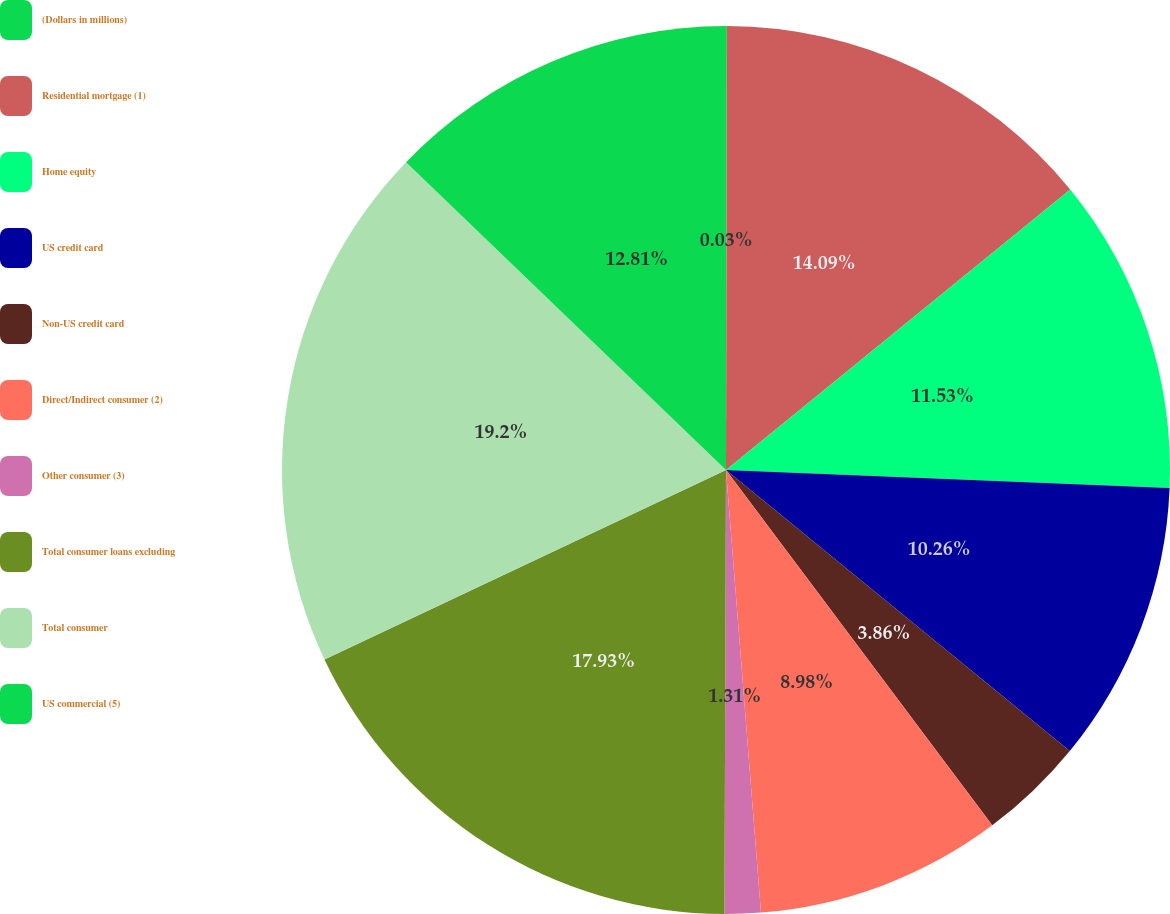Convert chart to OTSL. <chart><loc_0><loc_0><loc_500><loc_500><pie_chart><fcel>(Dollars in millions)<fcel>Residential mortgage (1)<fcel>Home equity<fcel>US credit card<fcel>Non-US credit card<fcel>Direct/Indirect consumer (2)<fcel>Other consumer (3)<fcel>Total consumer loans excluding<fcel>Total consumer<fcel>US commercial (5)<nl><fcel>0.03%<fcel>14.09%<fcel>11.53%<fcel>10.26%<fcel>3.86%<fcel>8.98%<fcel>1.31%<fcel>17.93%<fcel>19.21%<fcel>12.81%<nl></chart> 